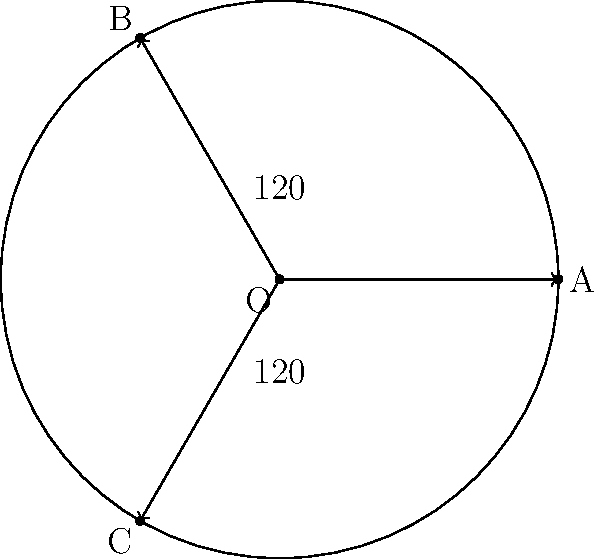In a targeted radiation therapy plan, three radiation beams are directed at a tumor located at point O. The beams are represented by vectors OA, OB, and OC, forming equal angles of 120° between each other. If the radius of the circular tumor is 2 units, and beam OA is aligned with the positive x-axis, what are the coordinates of points B and C? To solve this problem, we'll follow these steps:

1) First, we know that point A is on the positive x-axis with a distance of 2 units from O. So, A = (2, 0).

2) The angle between each beam is 120°. We can use this to find the angles of OB and OC from the positive x-axis:
   - Angle of OB = 120°
   - Angle of OC = 240°

3) We can use polar coordinates to find B and C. The general form is:
   $$(r \cos \theta, r \sin \theta)$$
   where r is the radius (2 in this case) and θ is the angle.

4) For point B:
   $x = 2 \cos 120° = 2 \cdot (-0.5) = -1$
   $y = 2 \sin 120° = 2 \cdot (\frac{\sqrt{3}}{2}) = \sqrt{3} \approx 1.732$

5) For point C:
   $x = 2 \cos 240° = 2 \cdot (-0.5) = -1$
   $y = 2 \sin 240° = 2 \cdot (-\frac{\sqrt{3}}{2}) = -\sqrt{3} \approx -1.732$

Therefore, the coordinates are:
B = (-1, $\sqrt{3}$) ≈ (-1, 1.732)
C = (-1, -$\sqrt{3}$) ≈ (-1, -1.732)
Answer: B = (-1, $\sqrt{3}$), C = (-1, -$\sqrt{3}$) 